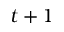<formula> <loc_0><loc_0><loc_500><loc_500>t + 1</formula> 